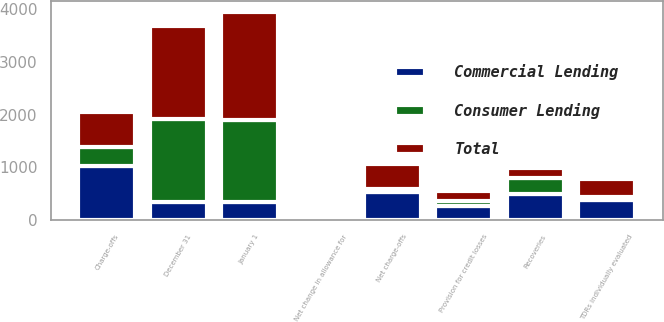Convert chart to OTSL. <chart><loc_0><loc_0><loc_500><loc_500><stacked_bar_chart><ecel><fcel>January 1<fcel>Charge-offs<fcel>Recoveries<fcel>Net charge-offs<fcel>Provision for credit losses<fcel>Net change in allowance for<fcel>December 31<fcel>TDRs individually evaluated<nl><fcel>Consumer Lending<fcel>1547<fcel>360<fcel>305<fcel>55<fcel>100<fcel>18<fcel>1571<fcel>62<nl><fcel>Total<fcel>2062<fcel>661<fcel>185<fcel>476<fcel>173<fcel>1<fcel>1760<fcel>324<nl><fcel>Commercial Lending<fcel>342<fcel>1021<fcel>490<fcel>531<fcel>273<fcel>17<fcel>342<fcel>386<nl></chart> 